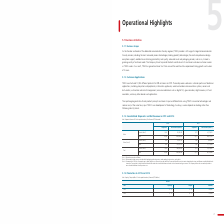According to Taiwan Semiconductor Manufacturing Co's financial document, What is meant by Domestic? According to the financial document, sales to Taiwan. The relevant text states: "Note 1: Domestic means sales to Taiwan. Note 2: Others mainly include revenue associated with packaging and testing services, mask making,..." Also, What is included in others? revenue associated with packaging and testing services, mask making, design services, and royalties.. The document states: "ans sales to Taiwan. Note 2: Others mainly include revenue associated with packaging and testing services, mask making, design services, and royalties..." Also, How did the the Company began to break down the net revenue by product since 2018? based on a new method which associates most estimated sales returns and allowances with individual sales transactions, as opposed to the previous method which allocated sales returns and allowances based on the aforementioned gross revenue.. The document states: "any began to break down the net revenue by product based on a new method which associates most estimated sales returns and allowances with individual ..." Also, can you calculate: What is the change in Wafer Domestic Shipments between 2018 and 2019? Based on the calculation: 1,678-1,575, the result is 103 (in thousands). This is based on the information: "Wafer Domestic (Note 1) 1,678 91,259,259 1,575 81,718,513 Wafer Domestic (Note 1) 1,678 91,259,259 1,575 81,718,513..." The key data points involved are: 1,575, 1,678. Also, can you calculate: What is the change in Wafer Domestic Net Revenue between 2018 and 2019? Based on the calculation: 91,259,259-81,718,513, the result is 9540746 (in thousands). This is based on the information: "Wafer Domestic (Note 1) 1,678 91,259,259 1,575 81,718,513 Wafer Domestic (Note 1) 1,678 91,259,259 1,575 81,718,513..." The key data points involved are: 81,718,513, 91,259,259. Also, can you calculate: What is the change in Others Domestic Net Revenue between 2018 and 2019? Based on the calculation: 8,835,783-8,398,094, the result is 437689 (in thousands). This is based on the information: "hers (Note 2) Domestic (Note 1) N/A 8,835,783 N/A 8,398,094 Others (Note 2) Domestic (Note 1) N/A 8,835,783 N/A 8,398,094..." The key data points involved are: 8,398,094, 8,835,783. 